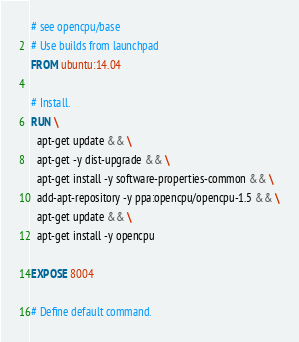<code> <loc_0><loc_0><loc_500><loc_500><_Dockerfile_># see opencpu/base
# Use builds from launchpad
FROM ubuntu:14.04

# Install.
RUN \
  apt-get update && \
  apt-get -y dist-upgrade && \
  apt-get install -y software-properties-common && \
  add-apt-repository -y ppa:opencpu/opencpu-1.5 && \
  apt-get update && \
  apt-get install -y opencpu

EXPOSE 8004

# Define default command.</code> 